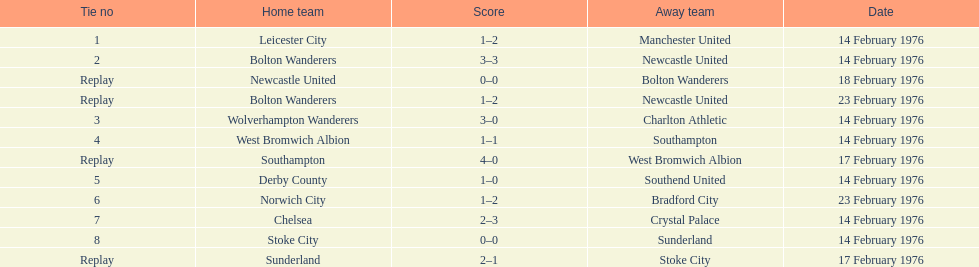How many contests did the bolton wanderers and newcastle united engage in before a definite champion was determined in the fifth round proper? 3. 